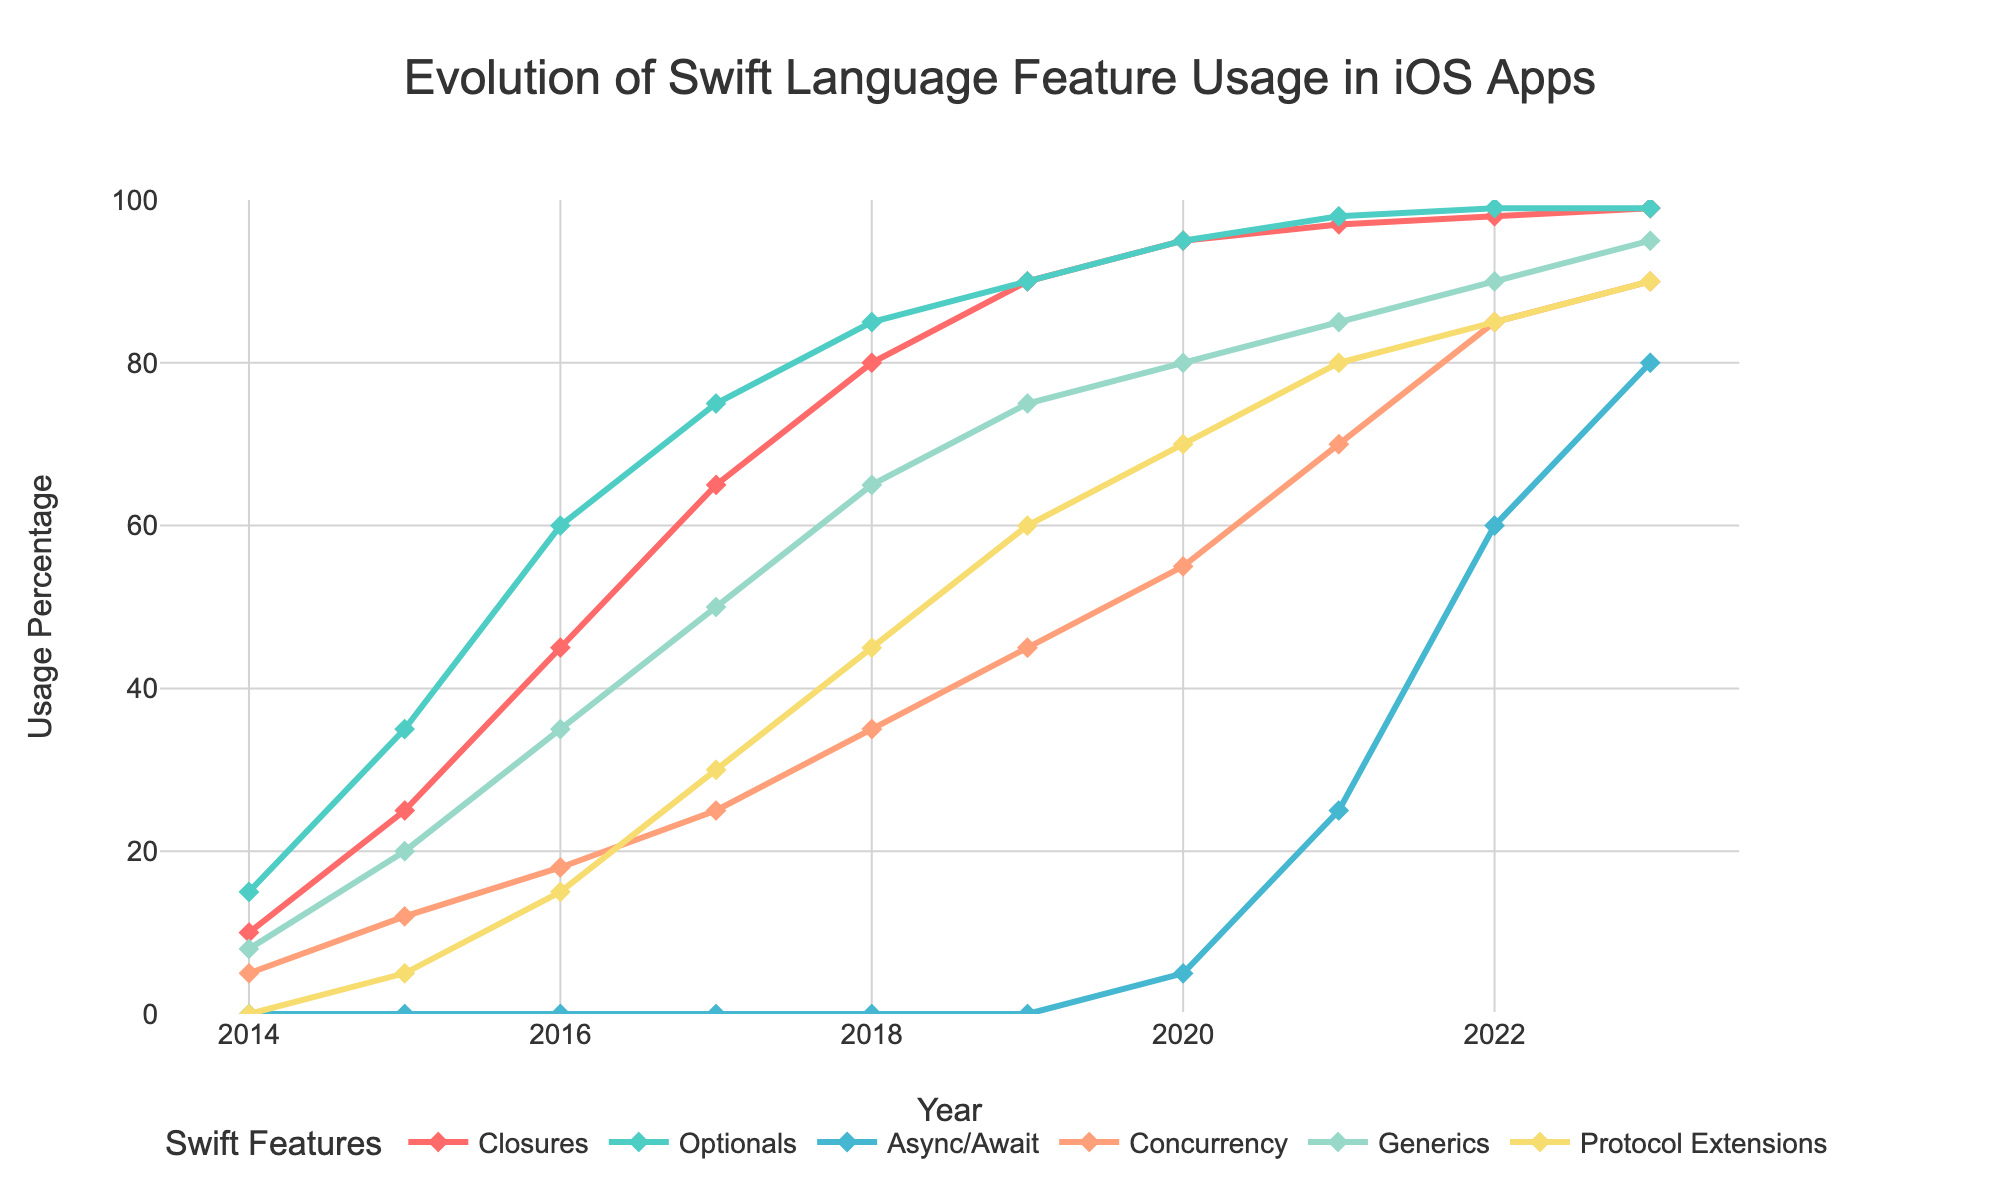What was the usage percentage of Protocol Extensions in 2016 compared to 2018? In 2016, Protocol Extensions had a usage percentage of 15%. In 2018, this had increased to 45%. Therefore, the usage percentage in 2018 was significantly higher than in 2016.
Answer: Higher in 2018 Which feature had the steepest increase in usage between 2016 and 2023? From 2016 to 2023, Async/Await had the steepest increase, starting from 0% in 2016 and reaching 80% in 2023. No other feature shows such a drastic increase in this timeframe.
Answer: Async/Await In which year did the usage percentage of Optionals first exceed 50%? According to the data, the usage percentage of Optionals exceeded 50% for the first time in 2016, where it reached 60%.
Answer: 2016 What is the average usage percentage of Generics over the years 2014 to 2023? Summing the usage percentages from 2014 to 2023 for Generics: 8 + 20 + 35 + 50 + 65 + 75 + 80 + 85 + 90 + 95 = 603. There are 10 years, so the average is 603 / 10 = 60.3.
Answer: 60.3 Which feature had a usage percentage of 0% until 2020? According to the data, Async/Await had a usage percentage of 0% until 2020 when it reached 5%.
Answer: Async/Await Did Concurrency usage ever surpass Optionals? If so, in which year(s)? Optionals always had higher or equal usage percentages compared to Concurrency in all the years.
Answer: No What was the difference in usage percentages between Closures and Protocol Extensions in 2021? In 2021, Closures had a usage percentage of 97%, whereas Protocol Extensions had 80%. The difference is 97 - 80 = 17.
Answer: 17 How did the usage of Concurrency change between 2015 and 2023? In 2015, Concurrency usage was at 12% and steadily increased each year, reaching 90% in 2023. This shows a consistent upward trend.
Answer: Increased Which two features had the closest usage percentages in 2019 and what were those percentages? In 2019, Closures and Optionals both had usage percentages of 90%. This was the closest usage percentage of any two features in that year.
Answer: Closures and Optionals, 90% 